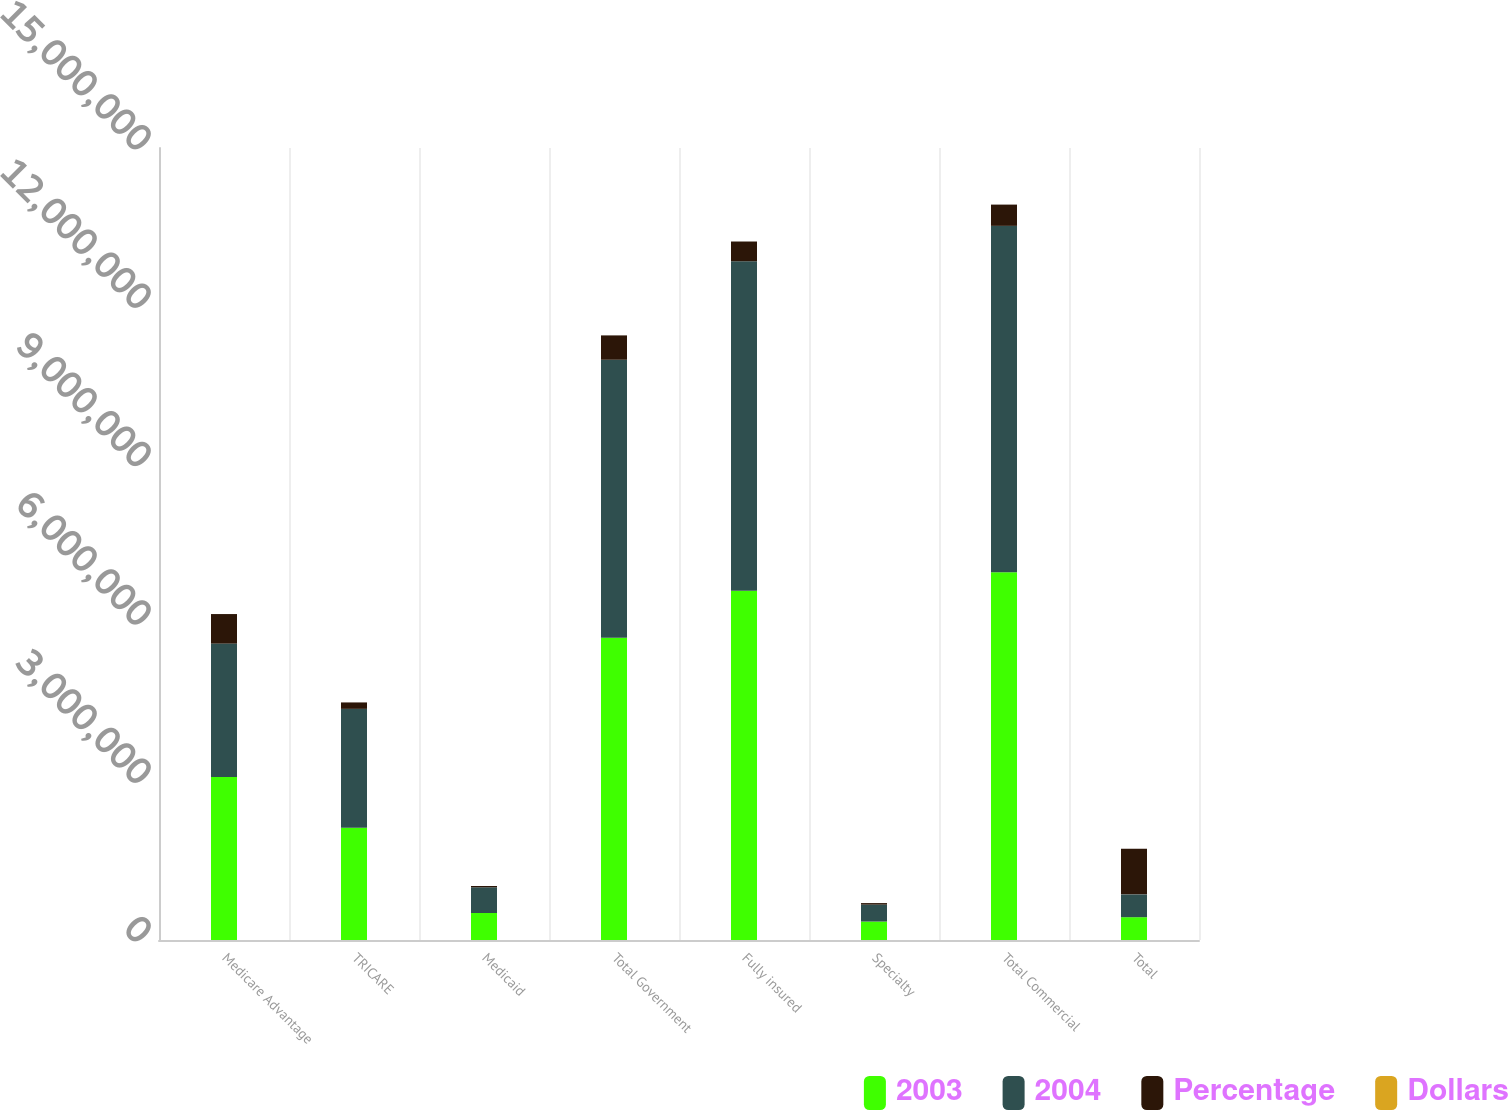Convert chart. <chart><loc_0><loc_0><loc_500><loc_500><stacked_bar_chart><ecel><fcel>Medicare Advantage<fcel>TRICARE<fcel>Medicaid<fcel>Total Government<fcel>Fully insured<fcel>Specialty<fcel>Total Commercial<fcel>Total<nl><fcel>2003<fcel>3.0866e+06<fcel>2.1276e+06<fcel>511193<fcel>5.72539e+06<fcel>6.61448e+06<fcel>349564<fcel>6.96405e+06<fcel>432074<nl><fcel>2004<fcel>2.52745e+06<fcel>2.24972e+06<fcel>487100<fcel>5.26427e+06<fcel>6.24081e+06<fcel>320206<fcel>6.56101e+06<fcel>432074<nl><fcel>Percentage<fcel>559152<fcel>122130<fcel>24093<fcel>461115<fcel>373676<fcel>29358<fcel>403034<fcel>864149<nl><fcel>Dollars<fcel>22.1<fcel>5.4<fcel>4.9<fcel>8.8<fcel>6<fcel>9.2<fcel>6.1<fcel>7.3<nl></chart> 